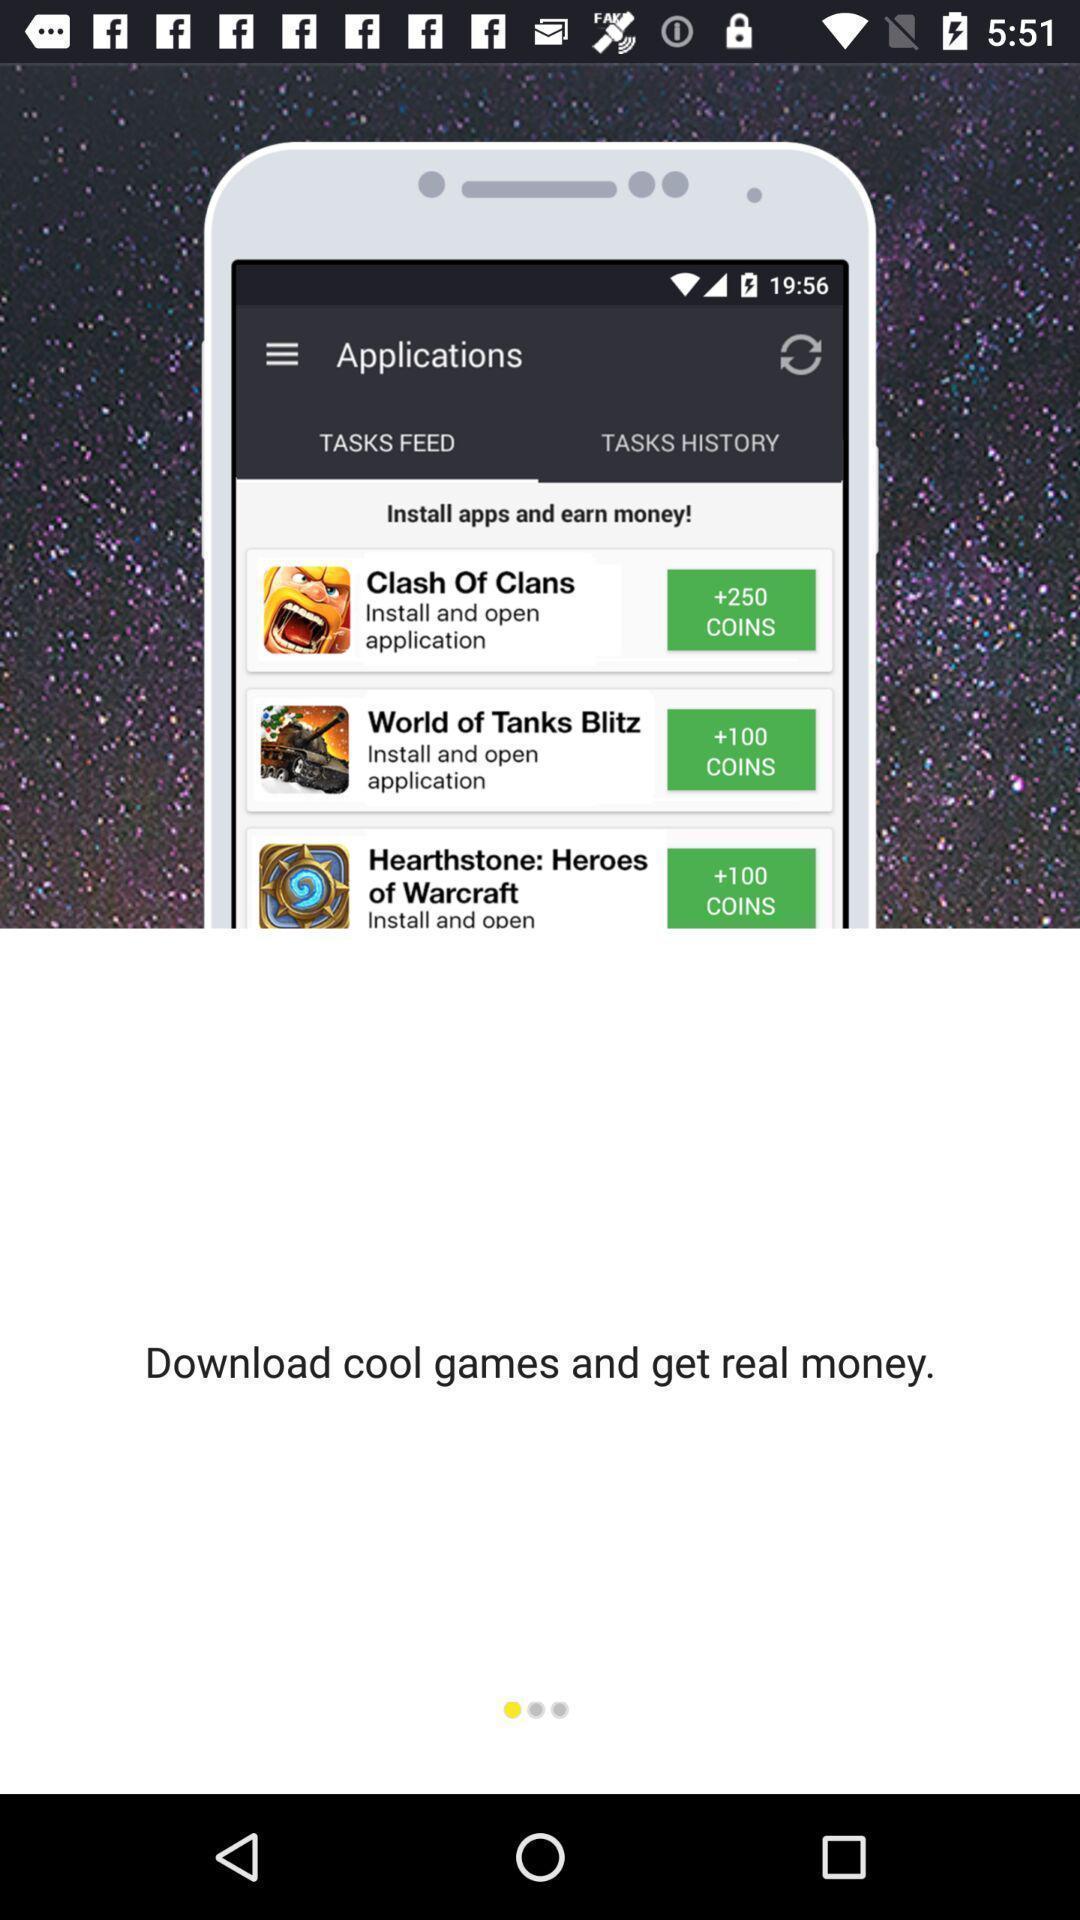Summarize the information in this screenshot. Pop up showing to download cool game. 